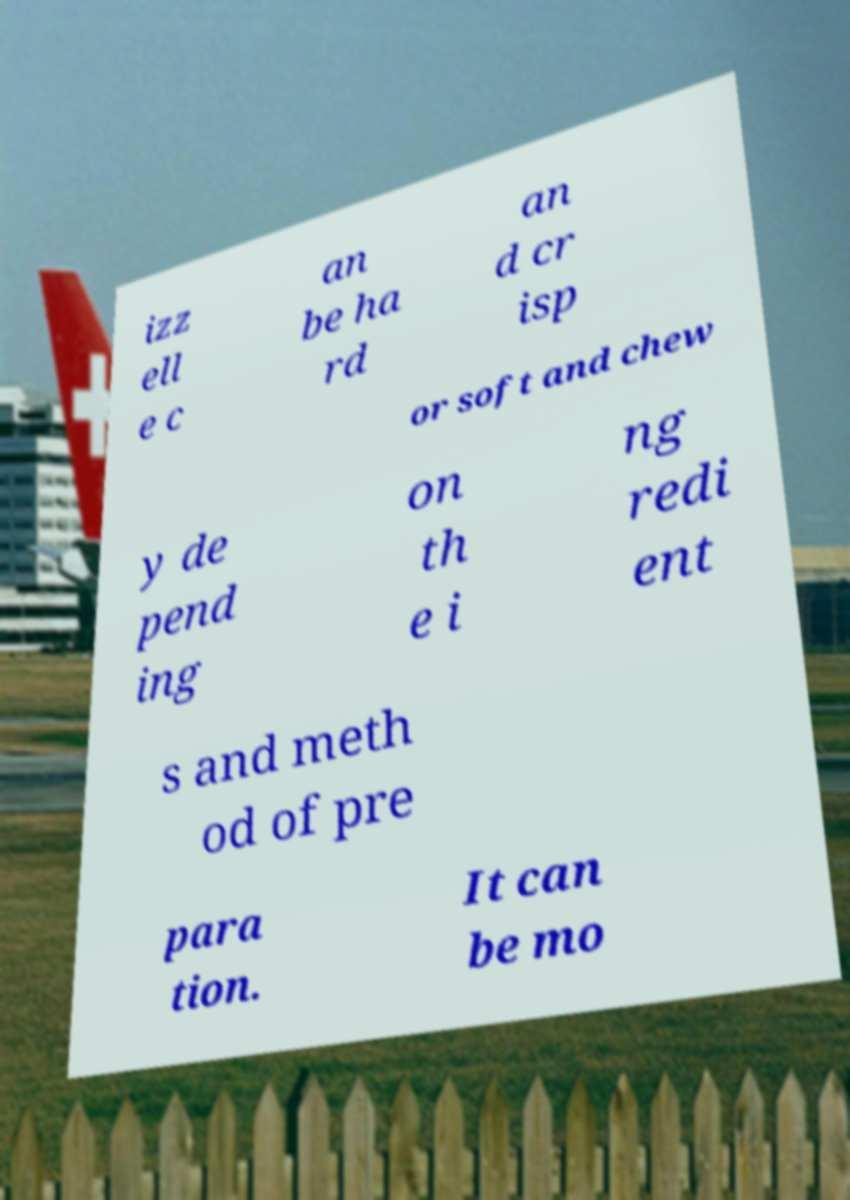Can you accurately transcribe the text from the provided image for me? izz ell e c an be ha rd an d cr isp or soft and chew y de pend ing on th e i ng redi ent s and meth od of pre para tion. It can be mo 